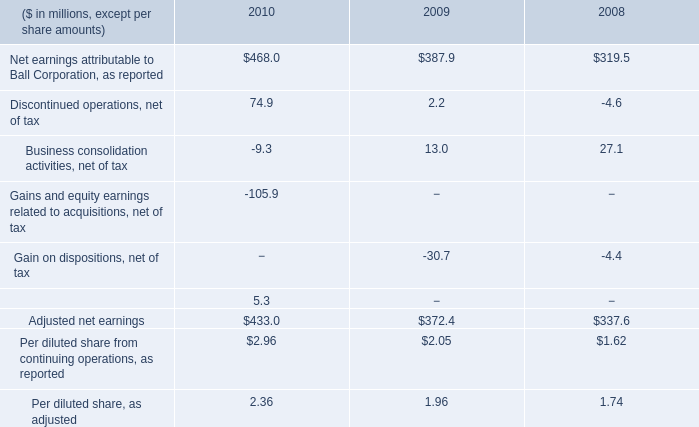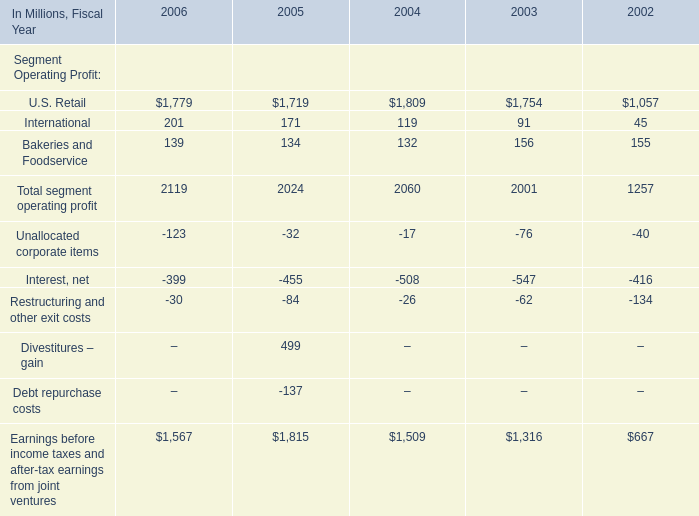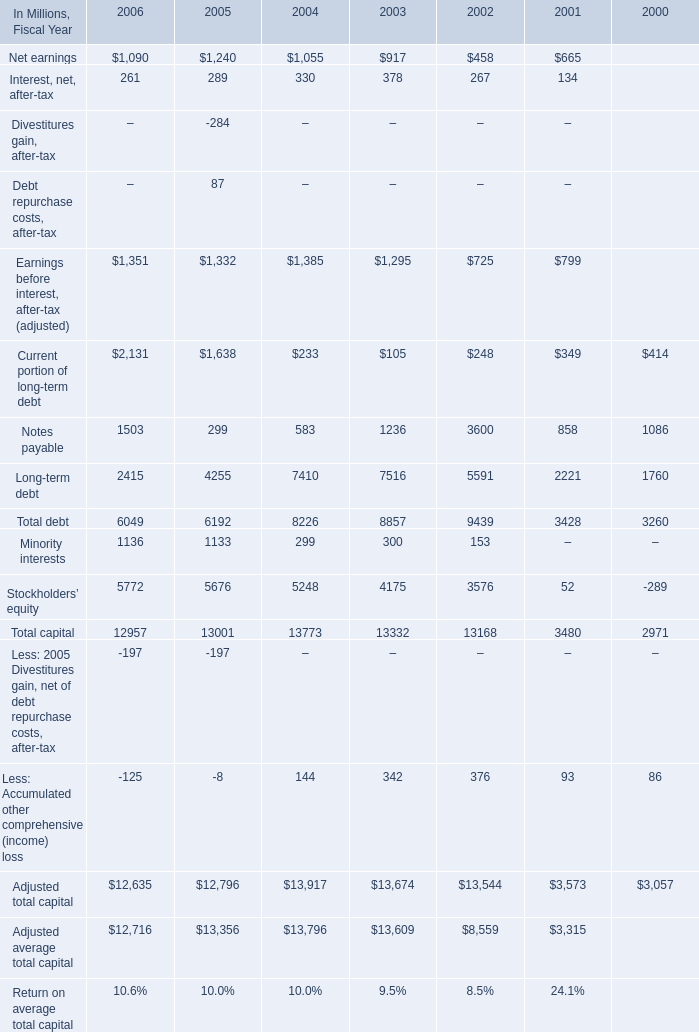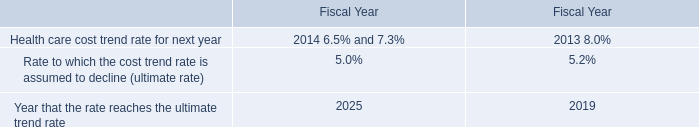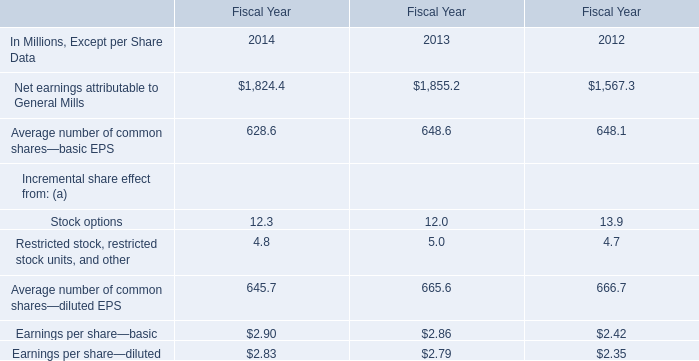In Fiscal Year 2004, what do all Segment Operating Profit sum up,excluding those ones less than 1000 Million? (in million) 
Answer: 1809. 